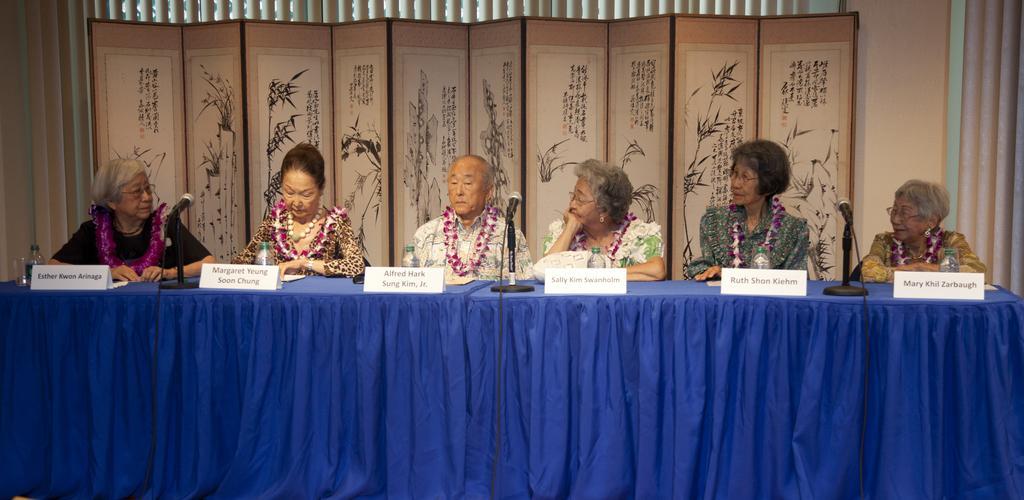Can you describe this image briefly? In this image there are six persons sitting on the chair. On the table there is bottle,mic. 